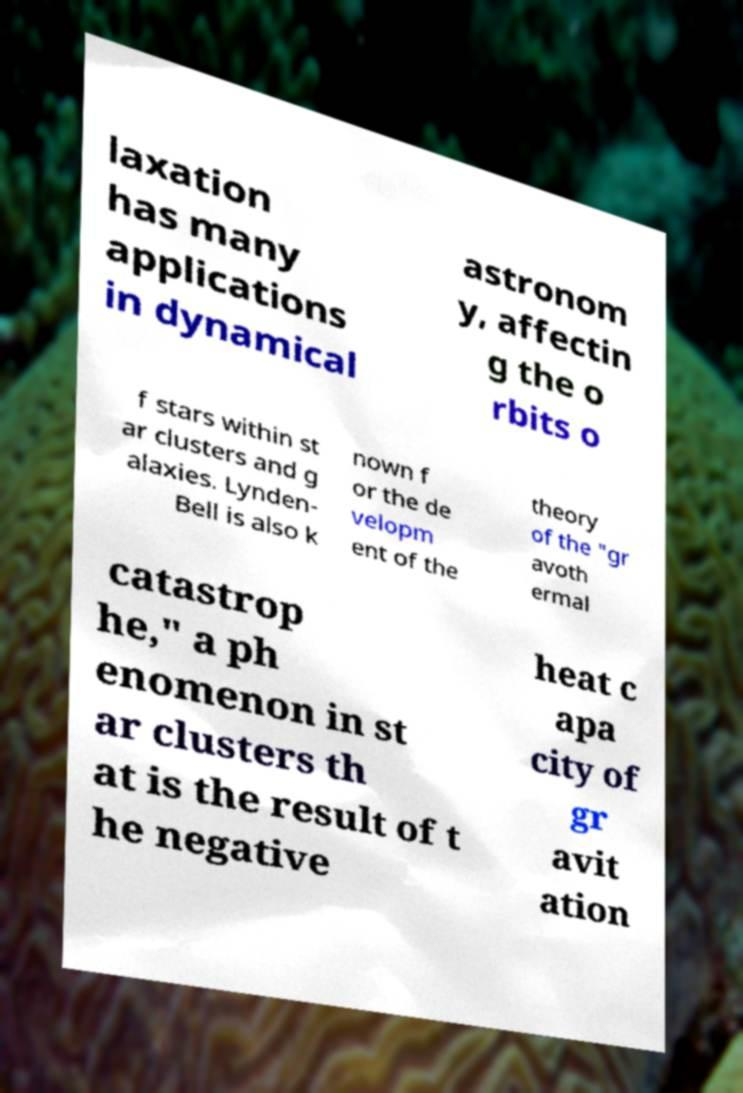Please identify and transcribe the text found in this image. laxation has many applications in dynamical astronom y, affectin g the o rbits o f stars within st ar clusters and g alaxies. Lynden- Bell is also k nown f or the de velopm ent of the theory of the "gr avoth ermal catastrop he," a ph enomenon in st ar clusters th at is the result of t he negative heat c apa city of gr avit ation 